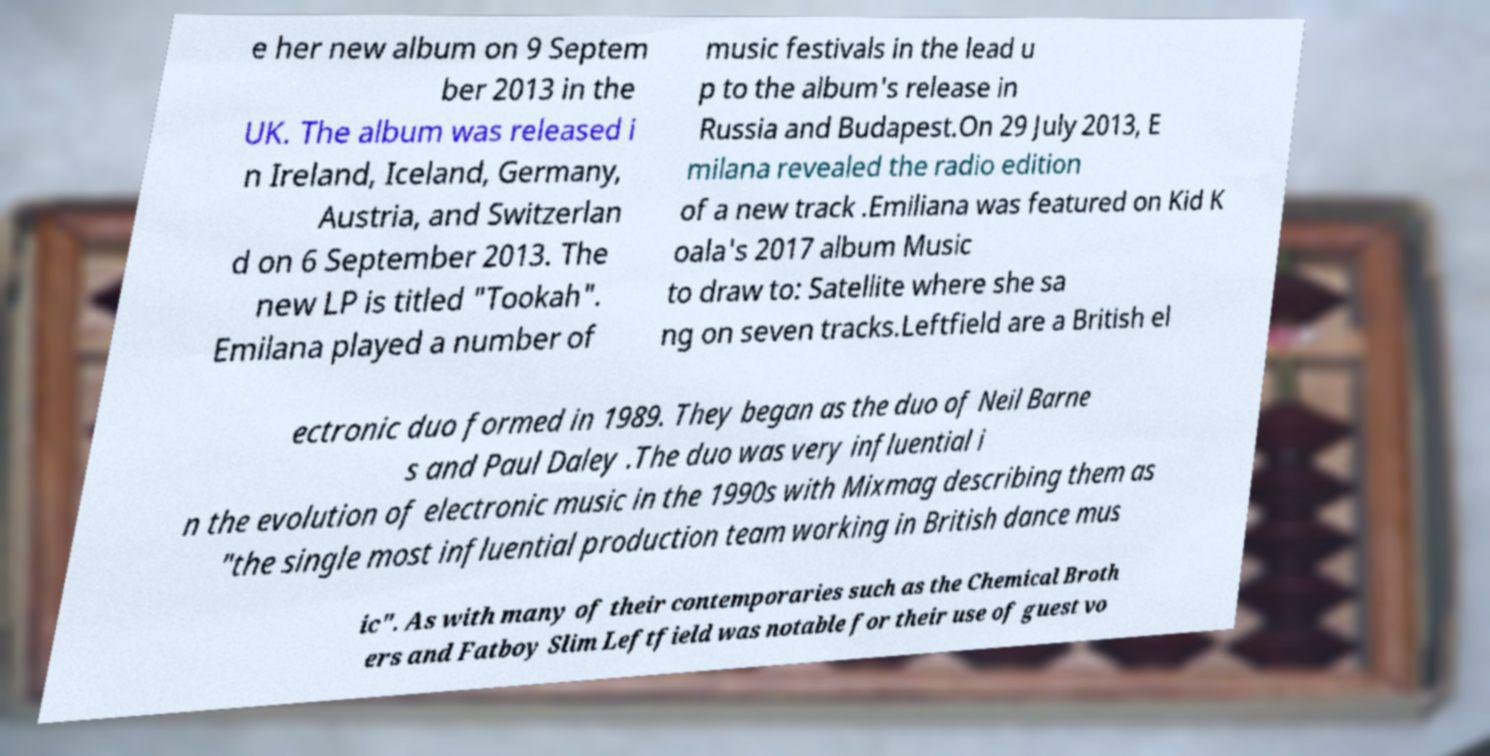There's text embedded in this image that I need extracted. Can you transcribe it verbatim? e her new album on 9 Septem ber 2013 in the UK. The album was released i n Ireland, Iceland, Germany, Austria, and Switzerlan d on 6 September 2013. The new LP is titled "Tookah". Emilana played a number of music festivals in the lead u p to the album's release in Russia and Budapest.On 29 July 2013, E milana revealed the radio edition of a new track .Emiliana was featured on Kid K oala's 2017 album Music to draw to: Satellite where she sa ng on seven tracks.Leftfield are a British el ectronic duo formed in 1989. They began as the duo of Neil Barne s and Paul Daley .The duo was very influential i n the evolution of electronic music in the 1990s with Mixmag describing them as "the single most influential production team working in British dance mus ic". As with many of their contemporaries such as the Chemical Broth ers and Fatboy Slim Leftfield was notable for their use of guest vo 